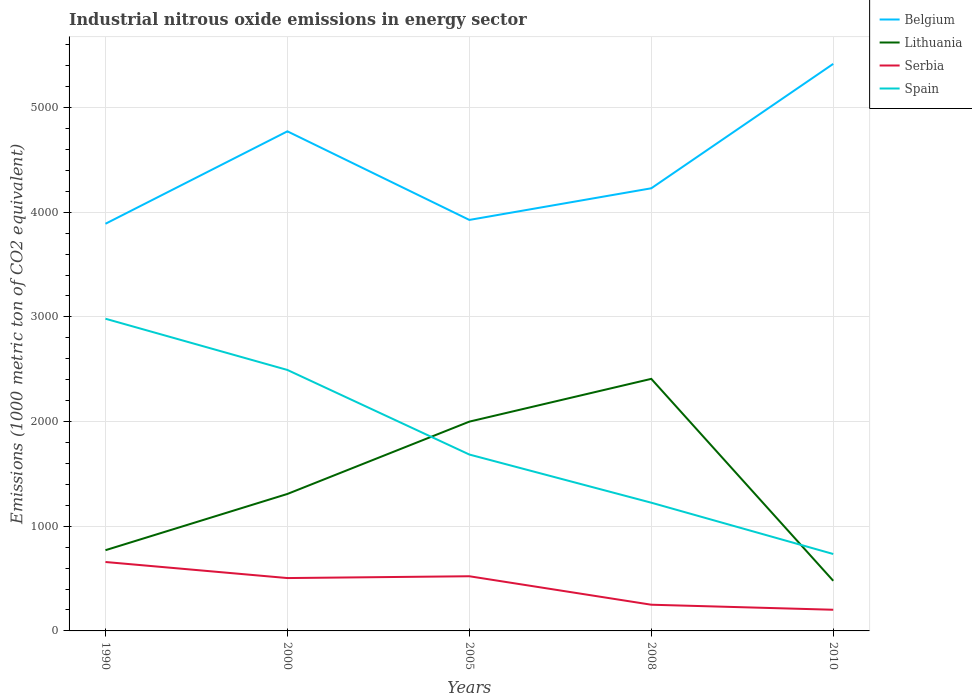Does the line corresponding to Serbia intersect with the line corresponding to Lithuania?
Your answer should be compact. No. Is the number of lines equal to the number of legend labels?
Ensure brevity in your answer.  Yes. Across all years, what is the maximum amount of industrial nitrous oxide emitted in Serbia?
Make the answer very short. 202.3. What is the total amount of industrial nitrous oxide emitted in Lithuania in the graph?
Provide a succinct answer. -537.3. What is the difference between the highest and the second highest amount of industrial nitrous oxide emitted in Lithuania?
Give a very brief answer. 1929.2. What is the difference between the highest and the lowest amount of industrial nitrous oxide emitted in Serbia?
Provide a succinct answer. 3. Is the amount of industrial nitrous oxide emitted in Spain strictly greater than the amount of industrial nitrous oxide emitted in Lithuania over the years?
Provide a succinct answer. No. How many lines are there?
Your answer should be compact. 4. How many years are there in the graph?
Keep it short and to the point. 5. What is the difference between two consecutive major ticks on the Y-axis?
Your answer should be compact. 1000. Does the graph contain any zero values?
Give a very brief answer. No. Where does the legend appear in the graph?
Keep it short and to the point. Top right. How are the legend labels stacked?
Your answer should be very brief. Vertical. What is the title of the graph?
Give a very brief answer. Industrial nitrous oxide emissions in energy sector. What is the label or title of the X-axis?
Provide a short and direct response. Years. What is the label or title of the Y-axis?
Keep it short and to the point. Emissions (1000 metric ton of CO2 equivalent). What is the Emissions (1000 metric ton of CO2 equivalent) of Belgium in 1990?
Your response must be concise. 3889.6. What is the Emissions (1000 metric ton of CO2 equivalent) in Lithuania in 1990?
Your response must be concise. 771.2. What is the Emissions (1000 metric ton of CO2 equivalent) of Serbia in 1990?
Make the answer very short. 658.4. What is the Emissions (1000 metric ton of CO2 equivalent) of Spain in 1990?
Give a very brief answer. 2982.4. What is the Emissions (1000 metric ton of CO2 equivalent) of Belgium in 2000?
Offer a very short reply. 4772.6. What is the Emissions (1000 metric ton of CO2 equivalent) in Lithuania in 2000?
Give a very brief answer. 1308.5. What is the Emissions (1000 metric ton of CO2 equivalent) of Serbia in 2000?
Keep it short and to the point. 505. What is the Emissions (1000 metric ton of CO2 equivalent) of Spain in 2000?
Provide a short and direct response. 2493. What is the Emissions (1000 metric ton of CO2 equivalent) of Belgium in 2005?
Ensure brevity in your answer.  3926.3. What is the Emissions (1000 metric ton of CO2 equivalent) of Lithuania in 2005?
Keep it short and to the point. 1999.4. What is the Emissions (1000 metric ton of CO2 equivalent) of Serbia in 2005?
Offer a terse response. 522.3. What is the Emissions (1000 metric ton of CO2 equivalent) of Spain in 2005?
Provide a short and direct response. 1685.1. What is the Emissions (1000 metric ton of CO2 equivalent) in Belgium in 2008?
Ensure brevity in your answer.  4228.6. What is the Emissions (1000 metric ton of CO2 equivalent) in Lithuania in 2008?
Your answer should be compact. 2408. What is the Emissions (1000 metric ton of CO2 equivalent) in Serbia in 2008?
Give a very brief answer. 250.3. What is the Emissions (1000 metric ton of CO2 equivalent) of Spain in 2008?
Offer a terse response. 1224.9. What is the Emissions (1000 metric ton of CO2 equivalent) in Belgium in 2010?
Your answer should be compact. 5417.1. What is the Emissions (1000 metric ton of CO2 equivalent) of Lithuania in 2010?
Your response must be concise. 478.8. What is the Emissions (1000 metric ton of CO2 equivalent) in Serbia in 2010?
Make the answer very short. 202.3. What is the Emissions (1000 metric ton of CO2 equivalent) in Spain in 2010?
Provide a succinct answer. 734.8. Across all years, what is the maximum Emissions (1000 metric ton of CO2 equivalent) in Belgium?
Give a very brief answer. 5417.1. Across all years, what is the maximum Emissions (1000 metric ton of CO2 equivalent) of Lithuania?
Your response must be concise. 2408. Across all years, what is the maximum Emissions (1000 metric ton of CO2 equivalent) in Serbia?
Provide a succinct answer. 658.4. Across all years, what is the maximum Emissions (1000 metric ton of CO2 equivalent) in Spain?
Ensure brevity in your answer.  2982.4. Across all years, what is the minimum Emissions (1000 metric ton of CO2 equivalent) of Belgium?
Offer a very short reply. 3889.6. Across all years, what is the minimum Emissions (1000 metric ton of CO2 equivalent) in Lithuania?
Offer a very short reply. 478.8. Across all years, what is the minimum Emissions (1000 metric ton of CO2 equivalent) of Serbia?
Give a very brief answer. 202.3. Across all years, what is the minimum Emissions (1000 metric ton of CO2 equivalent) of Spain?
Provide a succinct answer. 734.8. What is the total Emissions (1000 metric ton of CO2 equivalent) of Belgium in the graph?
Offer a very short reply. 2.22e+04. What is the total Emissions (1000 metric ton of CO2 equivalent) in Lithuania in the graph?
Offer a terse response. 6965.9. What is the total Emissions (1000 metric ton of CO2 equivalent) in Serbia in the graph?
Your answer should be compact. 2138.3. What is the total Emissions (1000 metric ton of CO2 equivalent) of Spain in the graph?
Your response must be concise. 9120.2. What is the difference between the Emissions (1000 metric ton of CO2 equivalent) of Belgium in 1990 and that in 2000?
Your response must be concise. -883. What is the difference between the Emissions (1000 metric ton of CO2 equivalent) of Lithuania in 1990 and that in 2000?
Your answer should be compact. -537.3. What is the difference between the Emissions (1000 metric ton of CO2 equivalent) of Serbia in 1990 and that in 2000?
Your response must be concise. 153.4. What is the difference between the Emissions (1000 metric ton of CO2 equivalent) in Spain in 1990 and that in 2000?
Your answer should be very brief. 489.4. What is the difference between the Emissions (1000 metric ton of CO2 equivalent) in Belgium in 1990 and that in 2005?
Your answer should be very brief. -36.7. What is the difference between the Emissions (1000 metric ton of CO2 equivalent) of Lithuania in 1990 and that in 2005?
Make the answer very short. -1228.2. What is the difference between the Emissions (1000 metric ton of CO2 equivalent) in Serbia in 1990 and that in 2005?
Provide a short and direct response. 136.1. What is the difference between the Emissions (1000 metric ton of CO2 equivalent) in Spain in 1990 and that in 2005?
Your answer should be very brief. 1297.3. What is the difference between the Emissions (1000 metric ton of CO2 equivalent) of Belgium in 1990 and that in 2008?
Provide a short and direct response. -339. What is the difference between the Emissions (1000 metric ton of CO2 equivalent) in Lithuania in 1990 and that in 2008?
Make the answer very short. -1636.8. What is the difference between the Emissions (1000 metric ton of CO2 equivalent) in Serbia in 1990 and that in 2008?
Offer a very short reply. 408.1. What is the difference between the Emissions (1000 metric ton of CO2 equivalent) of Spain in 1990 and that in 2008?
Give a very brief answer. 1757.5. What is the difference between the Emissions (1000 metric ton of CO2 equivalent) in Belgium in 1990 and that in 2010?
Your answer should be compact. -1527.5. What is the difference between the Emissions (1000 metric ton of CO2 equivalent) in Lithuania in 1990 and that in 2010?
Make the answer very short. 292.4. What is the difference between the Emissions (1000 metric ton of CO2 equivalent) of Serbia in 1990 and that in 2010?
Make the answer very short. 456.1. What is the difference between the Emissions (1000 metric ton of CO2 equivalent) in Spain in 1990 and that in 2010?
Offer a terse response. 2247.6. What is the difference between the Emissions (1000 metric ton of CO2 equivalent) of Belgium in 2000 and that in 2005?
Give a very brief answer. 846.3. What is the difference between the Emissions (1000 metric ton of CO2 equivalent) in Lithuania in 2000 and that in 2005?
Give a very brief answer. -690.9. What is the difference between the Emissions (1000 metric ton of CO2 equivalent) of Serbia in 2000 and that in 2005?
Keep it short and to the point. -17.3. What is the difference between the Emissions (1000 metric ton of CO2 equivalent) in Spain in 2000 and that in 2005?
Ensure brevity in your answer.  807.9. What is the difference between the Emissions (1000 metric ton of CO2 equivalent) of Belgium in 2000 and that in 2008?
Your response must be concise. 544. What is the difference between the Emissions (1000 metric ton of CO2 equivalent) in Lithuania in 2000 and that in 2008?
Make the answer very short. -1099.5. What is the difference between the Emissions (1000 metric ton of CO2 equivalent) of Serbia in 2000 and that in 2008?
Your response must be concise. 254.7. What is the difference between the Emissions (1000 metric ton of CO2 equivalent) of Spain in 2000 and that in 2008?
Make the answer very short. 1268.1. What is the difference between the Emissions (1000 metric ton of CO2 equivalent) in Belgium in 2000 and that in 2010?
Provide a short and direct response. -644.5. What is the difference between the Emissions (1000 metric ton of CO2 equivalent) of Lithuania in 2000 and that in 2010?
Your answer should be very brief. 829.7. What is the difference between the Emissions (1000 metric ton of CO2 equivalent) in Serbia in 2000 and that in 2010?
Provide a short and direct response. 302.7. What is the difference between the Emissions (1000 metric ton of CO2 equivalent) in Spain in 2000 and that in 2010?
Ensure brevity in your answer.  1758.2. What is the difference between the Emissions (1000 metric ton of CO2 equivalent) in Belgium in 2005 and that in 2008?
Provide a short and direct response. -302.3. What is the difference between the Emissions (1000 metric ton of CO2 equivalent) of Lithuania in 2005 and that in 2008?
Offer a very short reply. -408.6. What is the difference between the Emissions (1000 metric ton of CO2 equivalent) of Serbia in 2005 and that in 2008?
Ensure brevity in your answer.  272. What is the difference between the Emissions (1000 metric ton of CO2 equivalent) of Spain in 2005 and that in 2008?
Provide a succinct answer. 460.2. What is the difference between the Emissions (1000 metric ton of CO2 equivalent) of Belgium in 2005 and that in 2010?
Your response must be concise. -1490.8. What is the difference between the Emissions (1000 metric ton of CO2 equivalent) of Lithuania in 2005 and that in 2010?
Your answer should be compact. 1520.6. What is the difference between the Emissions (1000 metric ton of CO2 equivalent) in Serbia in 2005 and that in 2010?
Keep it short and to the point. 320. What is the difference between the Emissions (1000 metric ton of CO2 equivalent) of Spain in 2005 and that in 2010?
Offer a very short reply. 950.3. What is the difference between the Emissions (1000 metric ton of CO2 equivalent) of Belgium in 2008 and that in 2010?
Your answer should be very brief. -1188.5. What is the difference between the Emissions (1000 metric ton of CO2 equivalent) of Lithuania in 2008 and that in 2010?
Give a very brief answer. 1929.2. What is the difference between the Emissions (1000 metric ton of CO2 equivalent) of Spain in 2008 and that in 2010?
Ensure brevity in your answer.  490.1. What is the difference between the Emissions (1000 metric ton of CO2 equivalent) of Belgium in 1990 and the Emissions (1000 metric ton of CO2 equivalent) of Lithuania in 2000?
Your answer should be very brief. 2581.1. What is the difference between the Emissions (1000 metric ton of CO2 equivalent) in Belgium in 1990 and the Emissions (1000 metric ton of CO2 equivalent) in Serbia in 2000?
Give a very brief answer. 3384.6. What is the difference between the Emissions (1000 metric ton of CO2 equivalent) of Belgium in 1990 and the Emissions (1000 metric ton of CO2 equivalent) of Spain in 2000?
Your response must be concise. 1396.6. What is the difference between the Emissions (1000 metric ton of CO2 equivalent) in Lithuania in 1990 and the Emissions (1000 metric ton of CO2 equivalent) in Serbia in 2000?
Give a very brief answer. 266.2. What is the difference between the Emissions (1000 metric ton of CO2 equivalent) in Lithuania in 1990 and the Emissions (1000 metric ton of CO2 equivalent) in Spain in 2000?
Keep it short and to the point. -1721.8. What is the difference between the Emissions (1000 metric ton of CO2 equivalent) of Serbia in 1990 and the Emissions (1000 metric ton of CO2 equivalent) of Spain in 2000?
Offer a terse response. -1834.6. What is the difference between the Emissions (1000 metric ton of CO2 equivalent) of Belgium in 1990 and the Emissions (1000 metric ton of CO2 equivalent) of Lithuania in 2005?
Offer a terse response. 1890.2. What is the difference between the Emissions (1000 metric ton of CO2 equivalent) in Belgium in 1990 and the Emissions (1000 metric ton of CO2 equivalent) in Serbia in 2005?
Keep it short and to the point. 3367.3. What is the difference between the Emissions (1000 metric ton of CO2 equivalent) of Belgium in 1990 and the Emissions (1000 metric ton of CO2 equivalent) of Spain in 2005?
Make the answer very short. 2204.5. What is the difference between the Emissions (1000 metric ton of CO2 equivalent) of Lithuania in 1990 and the Emissions (1000 metric ton of CO2 equivalent) of Serbia in 2005?
Your answer should be compact. 248.9. What is the difference between the Emissions (1000 metric ton of CO2 equivalent) in Lithuania in 1990 and the Emissions (1000 metric ton of CO2 equivalent) in Spain in 2005?
Offer a very short reply. -913.9. What is the difference between the Emissions (1000 metric ton of CO2 equivalent) in Serbia in 1990 and the Emissions (1000 metric ton of CO2 equivalent) in Spain in 2005?
Your answer should be compact. -1026.7. What is the difference between the Emissions (1000 metric ton of CO2 equivalent) of Belgium in 1990 and the Emissions (1000 metric ton of CO2 equivalent) of Lithuania in 2008?
Keep it short and to the point. 1481.6. What is the difference between the Emissions (1000 metric ton of CO2 equivalent) of Belgium in 1990 and the Emissions (1000 metric ton of CO2 equivalent) of Serbia in 2008?
Your answer should be compact. 3639.3. What is the difference between the Emissions (1000 metric ton of CO2 equivalent) in Belgium in 1990 and the Emissions (1000 metric ton of CO2 equivalent) in Spain in 2008?
Your answer should be very brief. 2664.7. What is the difference between the Emissions (1000 metric ton of CO2 equivalent) in Lithuania in 1990 and the Emissions (1000 metric ton of CO2 equivalent) in Serbia in 2008?
Provide a short and direct response. 520.9. What is the difference between the Emissions (1000 metric ton of CO2 equivalent) of Lithuania in 1990 and the Emissions (1000 metric ton of CO2 equivalent) of Spain in 2008?
Ensure brevity in your answer.  -453.7. What is the difference between the Emissions (1000 metric ton of CO2 equivalent) in Serbia in 1990 and the Emissions (1000 metric ton of CO2 equivalent) in Spain in 2008?
Make the answer very short. -566.5. What is the difference between the Emissions (1000 metric ton of CO2 equivalent) of Belgium in 1990 and the Emissions (1000 metric ton of CO2 equivalent) of Lithuania in 2010?
Your response must be concise. 3410.8. What is the difference between the Emissions (1000 metric ton of CO2 equivalent) in Belgium in 1990 and the Emissions (1000 metric ton of CO2 equivalent) in Serbia in 2010?
Your response must be concise. 3687.3. What is the difference between the Emissions (1000 metric ton of CO2 equivalent) in Belgium in 1990 and the Emissions (1000 metric ton of CO2 equivalent) in Spain in 2010?
Make the answer very short. 3154.8. What is the difference between the Emissions (1000 metric ton of CO2 equivalent) in Lithuania in 1990 and the Emissions (1000 metric ton of CO2 equivalent) in Serbia in 2010?
Your answer should be very brief. 568.9. What is the difference between the Emissions (1000 metric ton of CO2 equivalent) in Lithuania in 1990 and the Emissions (1000 metric ton of CO2 equivalent) in Spain in 2010?
Provide a succinct answer. 36.4. What is the difference between the Emissions (1000 metric ton of CO2 equivalent) of Serbia in 1990 and the Emissions (1000 metric ton of CO2 equivalent) of Spain in 2010?
Make the answer very short. -76.4. What is the difference between the Emissions (1000 metric ton of CO2 equivalent) in Belgium in 2000 and the Emissions (1000 metric ton of CO2 equivalent) in Lithuania in 2005?
Your response must be concise. 2773.2. What is the difference between the Emissions (1000 metric ton of CO2 equivalent) in Belgium in 2000 and the Emissions (1000 metric ton of CO2 equivalent) in Serbia in 2005?
Provide a short and direct response. 4250.3. What is the difference between the Emissions (1000 metric ton of CO2 equivalent) of Belgium in 2000 and the Emissions (1000 metric ton of CO2 equivalent) of Spain in 2005?
Ensure brevity in your answer.  3087.5. What is the difference between the Emissions (1000 metric ton of CO2 equivalent) of Lithuania in 2000 and the Emissions (1000 metric ton of CO2 equivalent) of Serbia in 2005?
Offer a terse response. 786.2. What is the difference between the Emissions (1000 metric ton of CO2 equivalent) in Lithuania in 2000 and the Emissions (1000 metric ton of CO2 equivalent) in Spain in 2005?
Your answer should be very brief. -376.6. What is the difference between the Emissions (1000 metric ton of CO2 equivalent) of Serbia in 2000 and the Emissions (1000 metric ton of CO2 equivalent) of Spain in 2005?
Your response must be concise. -1180.1. What is the difference between the Emissions (1000 metric ton of CO2 equivalent) of Belgium in 2000 and the Emissions (1000 metric ton of CO2 equivalent) of Lithuania in 2008?
Your answer should be very brief. 2364.6. What is the difference between the Emissions (1000 metric ton of CO2 equivalent) in Belgium in 2000 and the Emissions (1000 metric ton of CO2 equivalent) in Serbia in 2008?
Keep it short and to the point. 4522.3. What is the difference between the Emissions (1000 metric ton of CO2 equivalent) in Belgium in 2000 and the Emissions (1000 metric ton of CO2 equivalent) in Spain in 2008?
Offer a very short reply. 3547.7. What is the difference between the Emissions (1000 metric ton of CO2 equivalent) of Lithuania in 2000 and the Emissions (1000 metric ton of CO2 equivalent) of Serbia in 2008?
Your answer should be compact. 1058.2. What is the difference between the Emissions (1000 metric ton of CO2 equivalent) of Lithuania in 2000 and the Emissions (1000 metric ton of CO2 equivalent) of Spain in 2008?
Ensure brevity in your answer.  83.6. What is the difference between the Emissions (1000 metric ton of CO2 equivalent) of Serbia in 2000 and the Emissions (1000 metric ton of CO2 equivalent) of Spain in 2008?
Offer a terse response. -719.9. What is the difference between the Emissions (1000 metric ton of CO2 equivalent) in Belgium in 2000 and the Emissions (1000 metric ton of CO2 equivalent) in Lithuania in 2010?
Provide a short and direct response. 4293.8. What is the difference between the Emissions (1000 metric ton of CO2 equivalent) in Belgium in 2000 and the Emissions (1000 metric ton of CO2 equivalent) in Serbia in 2010?
Your answer should be very brief. 4570.3. What is the difference between the Emissions (1000 metric ton of CO2 equivalent) in Belgium in 2000 and the Emissions (1000 metric ton of CO2 equivalent) in Spain in 2010?
Offer a very short reply. 4037.8. What is the difference between the Emissions (1000 metric ton of CO2 equivalent) of Lithuania in 2000 and the Emissions (1000 metric ton of CO2 equivalent) of Serbia in 2010?
Offer a very short reply. 1106.2. What is the difference between the Emissions (1000 metric ton of CO2 equivalent) of Lithuania in 2000 and the Emissions (1000 metric ton of CO2 equivalent) of Spain in 2010?
Make the answer very short. 573.7. What is the difference between the Emissions (1000 metric ton of CO2 equivalent) of Serbia in 2000 and the Emissions (1000 metric ton of CO2 equivalent) of Spain in 2010?
Your response must be concise. -229.8. What is the difference between the Emissions (1000 metric ton of CO2 equivalent) in Belgium in 2005 and the Emissions (1000 metric ton of CO2 equivalent) in Lithuania in 2008?
Ensure brevity in your answer.  1518.3. What is the difference between the Emissions (1000 metric ton of CO2 equivalent) of Belgium in 2005 and the Emissions (1000 metric ton of CO2 equivalent) of Serbia in 2008?
Offer a terse response. 3676. What is the difference between the Emissions (1000 metric ton of CO2 equivalent) of Belgium in 2005 and the Emissions (1000 metric ton of CO2 equivalent) of Spain in 2008?
Offer a very short reply. 2701.4. What is the difference between the Emissions (1000 metric ton of CO2 equivalent) in Lithuania in 2005 and the Emissions (1000 metric ton of CO2 equivalent) in Serbia in 2008?
Make the answer very short. 1749.1. What is the difference between the Emissions (1000 metric ton of CO2 equivalent) in Lithuania in 2005 and the Emissions (1000 metric ton of CO2 equivalent) in Spain in 2008?
Provide a short and direct response. 774.5. What is the difference between the Emissions (1000 metric ton of CO2 equivalent) in Serbia in 2005 and the Emissions (1000 metric ton of CO2 equivalent) in Spain in 2008?
Your answer should be compact. -702.6. What is the difference between the Emissions (1000 metric ton of CO2 equivalent) of Belgium in 2005 and the Emissions (1000 metric ton of CO2 equivalent) of Lithuania in 2010?
Offer a terse response. 3447.5. What is the difference between the Emissions (1000 metric ton of CO2 equivalent) in Belgium in 2005 and the Emissions (1000 metric ton of CO2 equivalent) in Serbia in 2010?
Ensure brevity in your answer.  3724. What is the difference between the Emissions (1000 metric ton of CO2 equivalent) of Belgium in 2005 and the Emissions (1000 metric ton of CO2 equivalent) of Spain in 2010?
Keep it short and to the point. 3191.5. What is the difference between the Emissions (1000 metric ton of CO2 equivalent) in Lithuania in 2005 and the Emissions (1000 metric ton of CO2 equivalent) in Serbia in 2010?
Your response must be concise. 1797.1. What is the difference between the Emissions (1000 metric ton of CO2 equivalent) of Lithuania in 2005 and the Emissions (1000 metric ton of CO2 equivalent) of Spain in 2010?
Make the answer very short. 1264.6. What is the difference between the Emissions (1000 metric ton of CO2 equivalent) in Serbia in 2005 and the Emissions (1000 metric ton of CO2 equivalent) in Spain in 2010?
Ensure brevity in your answer.  -212.5. What is the difference between the Emissions (1000 metric ton of CO2 equivalent) of Belgium in 2008 and the Emissions (1000 metric ton of CO2 equivalent) of Lithuania in 2010?
Offer a very short reply. 3749.8. What is the difference between the Emissions (1000 metric ton of CO2 equivalent) of Belgium in 2008 and the Emissions (1000 metric ton of CO2 equivalent) of Serbia in 2010?
Your response must be concise. 4026.3. What is the difference between the Emissions (1000 metric ton of CO2 equivalent) of Belgium in 2008 and the Emissions (1000 metric ton of CO2 equivalent) of Spain in 2010?
Your response must be concise. 3493.8. What is the difference between the Emissions (1000 metric ton of CO2 equivalent) in Lithuania in 2008 and the Emissions (1000 metric ton of CO2 equivalent) in Serbia in 2010?
Offer a very short reply. 2205.7. What is the difference between the Emissions (1000 metric ton of CO2 equivalent) of Lithuania in 2008 and the Emissions (1000 metric ton of CO2 equivalent) of Spain in 2010?
Give a very brief answer. 1673.2. What is the difference between the Emissions (1000 metric ton of CO2 equivalent) in Serbia in 2008 and the Emissions (1000 metric ton of CO2 equivalent) in Spain in 2010?
Provide a short and direct response. -484.5. What is the average Emissions (1000 metric ton of CO2 equivalent) of Belgium per year?
Keep it short and to the point. 4446.84. What is the average Emissions (1000 metric ton of CO2 equivalent) in Lithuania per year?
Your answer should be very brief. 1393.18. What is the average Emissions (1000 metric ton of CO2 equivalent) in Serbia per year?
Provide a succinct answer. 427.66. What is the average Emissions (1000 metric ton of CO2 equivalent) of Spain per year?
Your answer should be very brief. 1824.04. In the year 1990, what is the difference between the Emissions (1000 metric ton of CO2 equivalent) of Belgium and Emissions (1000 metric ton of CO2 equivalent) of Lithuania?
Ensure brevity in your answer.  3118.4. In the year 1990, what is the difference between the Emissions (1000 metric ton of CO2 equivalent) of Belgium and Emissions (1000 metric ton of CO2 equivalent) of Serbia?
Offer a very short reply. 3231.2. In the year 1990, what is the difference between the Emissions (1000 metric ton of CO2 equivalent) of Belgium and Emissions (1000 metric ton of CO2 equivalent) of Spain?
Your answer should be very brief. 907.2. In the year 1990, what is the difference between the Emissions (1000 metric ton of CO2 equivalent) in Lithuania and Emissions (1000 metric ton of CO2 equivalent) in Serbia?
Provide a succinct answer. 112.8. In the year 1990, what is the difference between the Emissions (1000 metric ton of CO2 equivalent) in Lithuania and Emissions (1000 metric ton of CO2 equivalent) in Spain?
Make the answer very short. -2211.2. In the year 1990, what is the difference between the Emissions (1000 metric ton of CO2 equivalent) of Serbia and Emissions (1000 metric ton of CO2 equivalent) of Spain?
Offer a very short reply. -2324. In the year 2000, what is the difference between the Emissions (1000 metric ton of CO2 equivalent) of Belgium and Emissions (1000 metric ton of CO2 equivalent) of Lithuania?
Keep it short and to the point. 3464.1. In the year 2000, what is the difference between the Emissions (1000 metric ton of CO2 equivalent) of Belgium and Emissions (1000 metric ton of CO2 equivalent) of Serbia?
Offer a very short reply. 4267.6. In the year 2000, what is the difference between the Emissions (1000 metric ton of CO2 equivalent) in Belgium and Emissions (1000 metric ton of CO2 equivalent) in Spain?
Keep it short and to the point. 2279.6. In the year 2000, what is the difference between the Emissions (1000 metric ton of CO2 equivalent) of Lithuania and Emissions (1000 metric ton of CO2 equivalent) of Serbia?
Your answer should be compact. 803.5. In the year 2000, what is the difference between the Emissions (1000 metric ton of CO2 equivalent) in Lithuania and Emissions (1000 metric ton of CO2 equivalent) in Spain?
Give a very brief answer. -1184.5. In the year 2000, what is the difference between the Emissions (1000 metric ton of CO2 equivalent) of Serbia and Emissions (1000 metric ton of CO2 equivalent) of Spain?
Keep it short and to the point. -1988. In the year 2005, what is the difference between the Emissions (1000 metric ton of CO2 equivalent) of Belgium and Emissions (1000 metric ton of CO2 equivalent) of Lithuania?
Your answer should be very brief. 1926.9. In the year 2005, what is the difference between the Emissions (1000 metric ton of CO2 equivalent) of Belgium and Emissions (1000 metric ton of CO2 equivalent) of Serbia?
Your response must be concise. 3404. In the year 2005, what is the difference between the Emissions (1000 metric ton of CO2 equivalent) in Belgium and Emissions (1000 metric ton of CO2 equivalent) in Spain?
Provide a short and direct response. 2241.2. In the year 2005, what is the difference between the Emissions (1000 metric ton of CO2 equivalent) of Lithuania and Emissions (1000 metric ton of CO2 equivalent) of Serbia?
Provide a succinct answer. 1477.1. In the year 2005, what is the difference between the Emissions (1000 metric ton of CO2 equivalent) of Lithuania and Emissions (1000 metric ton of CO2 equivalent) of Spain?
Your response must be concise. 314.3. In the year 2005, what is the difference between the Emissions (1000 metric ton of CO2 equivalent) in Serbia and Emissions (1000 metric ton of CO2 equivalent) in Spain?
Provide a short and direct response. -1162.8. In the year 2008, what is the difference between the Emissions (1000 metric ton of CO2 equivalent) of Belgium and Emissions (1000 metric ton of CO2 equivalent) of Lithuania?
Give a very brief answer. 1820.6. In the year 2008, what is the difference between the Emissions (1000 metric ton of CO2 equivalent) in Belgium and Emissions (1000 metric ton of CO2 equivalent) in Serbia?
Offer a very short reply. 3978.3. In the year 2008, what is the difference between the Emissions (1000 metric ton of CO2 equivalent) of Belgium and Emissions (1000 metric ton of CO2 equivalent) of Spain?
Keep it short and to the point. 3003.7. In the year 2008, what is the difference between the Emissions (1000 metric ton of CO2 equivalent) in Lithuania and Emissions (1000 metric ton of CO2 equivalent) in Serbia?
Offer a terse response. 2157.7. In the year 2008, what is the difference between the Emissions (1000 metric ton of CO2 equivalent) of Lithuania and Emissions (1000 metric ton of CO2 equivalent) of Spain?
Offer a terse response. 1183.1. In the year 2008, what is the difference between the Emissions (1000 metric ton of CO2 equivalent) in Serbia and Emissions (1000 metric ton of CO2 equivalent) in Spain?
Provide a succinct answer. -974.6. In the year 2010, what is the difference between the Emissions (1000 metric ton of CO2 equivalent) of Belgium and Emissions (1000 metric ton of CO2 equivalent) of Lithuania?
Give a very brief answer. 4938.3. In the year 2010, what is the difference between the Emissions (1000 metric ton of CO2 equivalent) in Belgium and Emissions (1000 metric ton of CO2 equivalent) in Serbia?
Your answer should be very brief. 5214.8. In the year 2010, what is the difference between the Emissions (1000 metric ton of CO2 equivalent) in Belgium and Emissions (1000 metric ton of CO2 equivalent) in Spain?
Make the answer very short. 4682.3. In the year 2010, what is the difference between the Emissions (1000 metric ton of CO2 equivalent) in Lithuania and Emissions (1000 metric ton of CO2 equivalent) in Serbia?
Keep it short and to the point. 276.5. In the year 2010, what is the difference between the Emissions (1000 metric ton of CO2 equivalent) of Lithuania and Emissions (1000 metric ton of CO2 equivalent) of Spain?
Offer a very short reply. -256. In the year 2010, what is the difference between the Emissions (1000 metric ton of CO2 equivalent) in Serbia and Emissions (1000 metric ton of CO2 equivalent) in Spain?
Keep it short and to the point. -532.5. What is the ratio of the Emissions (1000 metric ton of CO2 equivalent) of Belgium in 1990 to that in 2000?
Give a very brief answer. 0.81. What is the ratio of the Emissions (1000 metric ton of CO2 equivalent) of Lithuania in 1990 to that in 2000?
Give a very brief answer. 0.59. What is the ratio of the Emissions (1000 metric ton of CO2 equivalent) in Serbia in 1990 to that in 2000?
Ensure brevity in your answer.  1.3. What is the ratio of the Emissions (1000 metric ton of CO2 equivalent) of Spain in 1990 to that in 2000?
Provide a succinct answer. 1.2. What is the ratio of the Emissions (1000 metric ton of CO2 equivalent) of Belgium in 1990 to that in 2005?
Make the answer very short. 0.99. What is the ratio of the Emissions (1000 metric ton of CO2 equivalent) in Lithuania in 1990 to that in 2005?
Offer a terse response. 0.39. What is the ratio of the Emissions (1000 metric ton of CO2 equivalent) of Serbia in 1990 to that in 2005?
Your response must be concise. 1.26. What is the ratio of the Emissions (1000 metric ton of CO2 equivalent) of Spain in 1990 to that in 2005?
Your response must be concise. 1.77. What is the ratio of the Emissions (1000 metric ton of CO2 equivalent) of Belgium in 1990 to that in 2008?
Your response must be concise. 0.92. What is the ratio of the Emissions (1000 metric ton of CO2 equivalent) in Lithuania in 1990 to that in 2008?
Offer a very short reply. 0.32. What is the ratio of the Emissions (1000 metric ton of CO2 equivalent) of Serbia in 1990 to that in 2008?
Provide a short and direct response. 2.63. What is the ratio of the Emissions (1000 metric ton of CO2 equivalent) in Spain in 1990 to that in 2008?
Your answer should be very brief. 2.43. What is the ratio of the Emissions (1000 metric ton of CO2 equivalent) of Belgium in 1990 to that in 2010?
Give a very brief answer. 0.72. What is the ratio of the Emissions (1000 metric ton of CO2 equivalent) of Lithuania in 1990 to that in 2010?
Your answer should be compact. 1.61. What is the ratio of the Emissions (1000 metric ton of CO2 equivalent) of Serbia in 1990 to that in 2010?
Offer a terse response. 3.25. What is the ratio of the Emissions (1000 metric ton of CO2 equivalent) in Spain in 1990 to that in 2010?
Offer a very short reply. 4.06. What is the ratio of the Emissions (1000 metric ton of CO2 equivalent) of Belgium in 2000 to that in 2005?
Make the answer very short. 1.22. What is the ratio of the Emissions (1000 metric ton of CO2 equivalent) of Lithuania in 2000 to that in 2005?
Provide a succinct answer. 0.65. What is the ratio of the Emissions (1000 metric ton of CO2 equivalent) in Serbia in 2000 to that in 2005?
Provide a succinct answer. 0.97. What is the ratio of the Emissions (1000 metric ton of CO2 equivalent) of Spain in 2000 to that in 2005?
Give a very brief answer. 1.48. What is the ratio of the Emissions (1000 metric ton of CO2 equivalent) in Belgium in 2000 to that in 2008?
Provide a short and direct response. 1.13. What is the ratio of the Emissions (1000 metric ton of CO2 equivalent) in Lithuania in 2000 to that in 2008?
Provide a short and direct response. 0.54. What is the ratio of the Emissions (1000 metric ton of CO2 equivalent) in Serbia in 2000 to that in 2008?
Provide a succinct answer. 2.02. What is the ratio of the Emissions (1000 metric ton of CO2 equivalent) in Spain in 2000 to that in 2008?
Ensure brevity in your answer.  2.04. What is the ratio of the Emissions (1000 metric ton of CO2 equivalent) in Belgium in 2000 to that in 2010?
Make the answer very short. 0.88. What is the ratio of the Emissions (1000 metric ton of CO2 equivalent) of Lithuania in 2000 to that in 2010?
Your answer should be compact. 2.73. What is the ratio of the Emissions (1000 metric ton of CO2 equivalent) in Serbia in 2000 to that in 2010?
Keep it short and to the point. 2.5. What is the ratio of the Emissions (1000 metric ton of CO2 equivalent) in Spain in 2000 to that in 2010?
Offer a very short reply. 3.39. What is the ratio of the Emissions (1000 metric ton of CO2 equivalent) in Belgium in 2005 to that in 2008?
Your response must be concise. 0.93. What is the ratio of the Emissions (1000 metric ton of CO2 equivalent) of Lithuania in 2005 to that in 2008?
Ensure brevity in your answer.  0.83. What is the ratio of the Emissions (1000 metric ton of CO2 equivalent) in Serbia in 2005 to that in 2008?
Your answer should be compact. 2.09. What is the ratio of the Emissions (1000 metric ton of CO2 equivalent) in Spain in 2005 to that in 2008?
Provide a succinct answer. 1.38. What is the ratio of the Emissions (1000 metric ton of CO2 equivalent) of Belgium in 2005 to that in 2010?
Keep it short and to the point. 0.72. What is the ratio of the Emissions (1000 metric ton of CO2 equivalent) of Lithuania in 2005 to that in 2010?
Provide a short and direct response. 4.18. What is the ratio of the Emissions (1000 metric ton of CO2 equivalent) in Serbia in 2005 to that in 2010?
Provide a short and direct response. 2.58. What is the ratio of the Emissions (1000 metric ton of CO2 equivalent) in Spain in 2005 to that in 2010?
Your response must be concise. 2.29. What is the ratio of the Emissions (1000 metric ton of CO2 equivalent) in Belgium in 2008 to that in 2010?
Keep it short and to the point. 0.78. What is the ratio of the Emissions (1000 metric ton of CO2 equivalent) in Lithuania in 2008 to that in 2010?
Ensure brevity in your answer.  5.03. What is the ratio of the Emissions (1000 metric ton of CO2 equivalent) of Serbia in 2008 to that in 2010?
Offer a terse response. 1.24. What is the ratio of the Emissions (1000 metric ton of CO2 equivalent) in Spain in 2008 to that in 2010?
Provide a short and direct response. 1.67. What is the difference between the highest and the second highest Emissions (1000 metric ton of CO2 equivalent) in Belgium?
Your answer should be compact. 644.5. What is the difference between the highest and the second highest Emissions (1000 metric ton of CO2 equivalent) of Lithuania?
Provide a short and direct response. 408.6. What is the difference between the highest and the second highest Emissions (1000 metric ton of CO2 equivalent) in Serbia?
Give a very brief answer. 136.1. What is the difference between the highest and the second highest Emissions (1000 metric ton of CO2 equivalent) in Spain?
Provide a short and direct response. 489.4. What is the difference between the highest and the lowest Emissions (1000 metric ton of CO2 equivalent) of Belgium?
Keep it short and to the point. 1527.5. What is the difference between the highest and the lowest Emissions (1000 metric ton of CO2 equivalent) of Lithuania?
Your response must be concise. 1929.2. What is the difference between the highest and the lowest Emissions (1000 metric ton of CO2 equivalent) of Serbia?
Make the answer very short. 456.1. What is the difference between the highest and the lowest Emissions (1000 metric ton of CO2 equivalent) in Spain?
Offer a very short reply. 2247.6. 